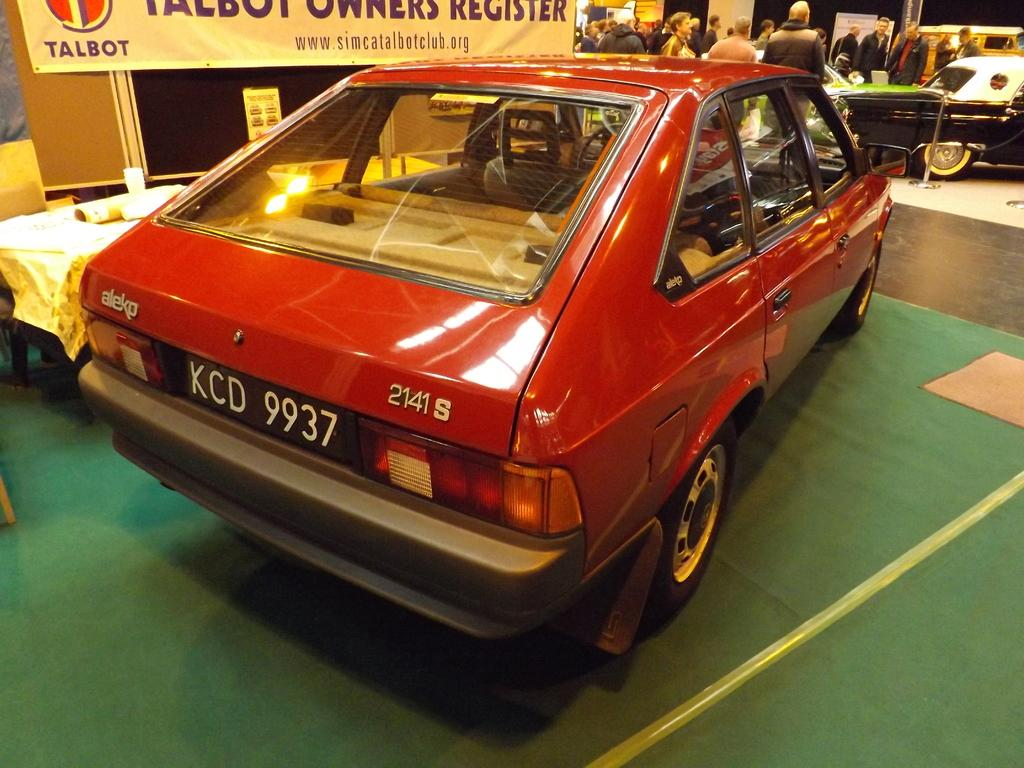What is on the floor in the image? There are vehicles on the floor in the image. What is happening with the people in the image? The people are standing in front of the vehicles. What can be seen beside the people and vehicles? There is a banner beside the people and vehicles. What other objects can be seen in the image? There are other objects visible in the image. What type of space-related object can be seen in the image? There is no space-related object present in the image. What is the reaction of the people to the vehicles in the image? The image does not show the people's reactions to the vehicles, so it cannot be determined from the image. 